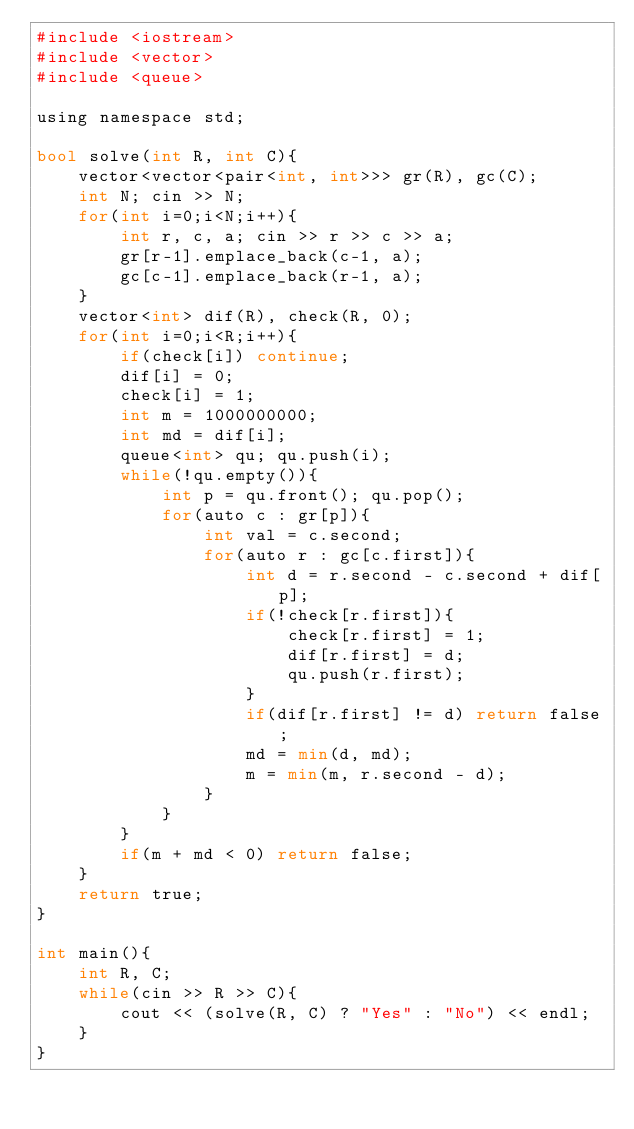<code> <loc_0><loc_0><loc_500><loc_500><_Python_>#include <iostream>
#include <vector>
#include <queue>

using namespace std;

bool solve(int R, int C){
    vector<vector<pair<int, int>>> gr(R), gc(C);
    int N; cin >> N;
    for(int i=0;i<N;i++){
        int r, c, a; cin >> r >> c >> a;
        gr[r-1].emplace_back(c-1, a);
        gc[c-1].emplace_back(r-1, a);
    }
    vector<int> dif(R), check(R, 0);
    for(int i=0;i<R;i++){
        if(check[i]) continue;
        dif[i] = 0;
        check[i] = 1;
        int m = 1000000000;
        int md = dif[i];
        queue<int> qu; qu.push(i);
        while(!qu.empty()){
            int p = qu.front(); qu.pop();
            for(auto c : gr[p]){
                int val = c.second;
                for(auto r : gc[c.first]){
                    int d = r.second - c.second + dif[p];
                    if(!check[r.first]){
                        check[r.first] = 1;
                        dif[r.first] = d;
                        qu.push(r.first);
                    }
                    if(dif[r.first] != d) return false;
                    md = min(d, md);
                    m = min(m, r.second - d);
                }
            }
        }
        if(m + md < 0) return false;
    }
    return true;
}

int main(){
    int R, C;
    while(cin >> R >> C){
        cout << (solve(R, C) ? "Yes" : "No") << endl;
    }
}</code> 